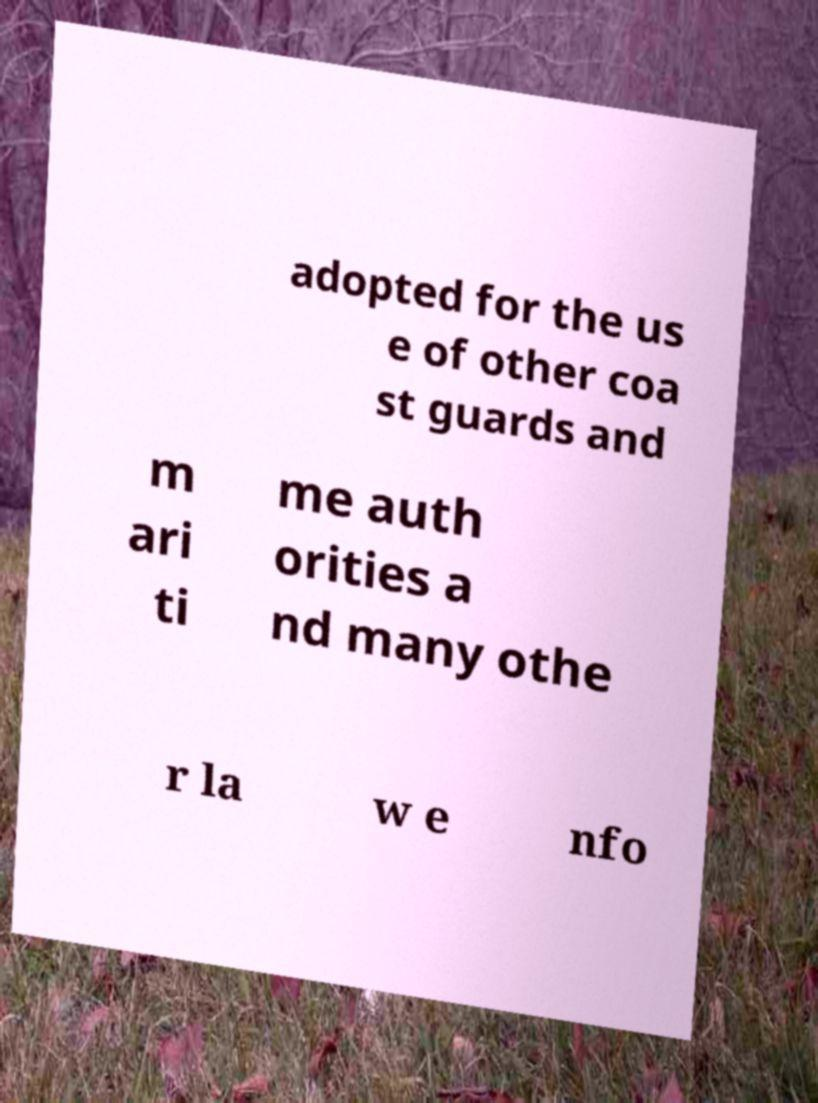Please identify and transcribe the text found in this image. adopted for the us e of other coa st guards and m ari ti me auth orities a nd many othe r la w e nfo 